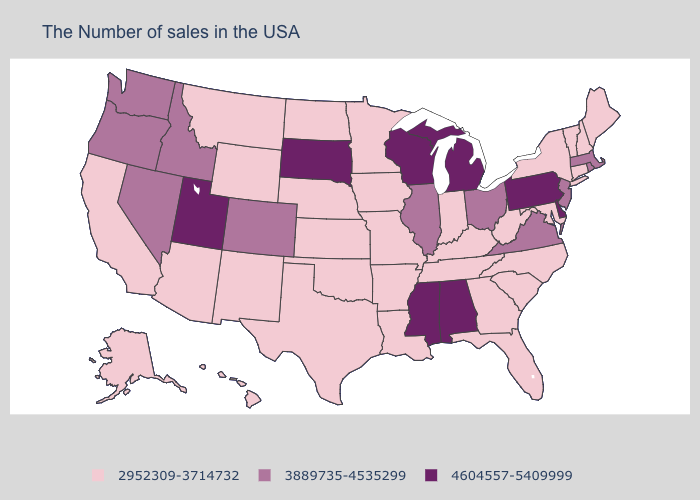Does the map have missing data?
Give a very brief answer. No. What is the highest value in states that border Kentucky?
Write a very short answer. 3889735-4535299. Is the legend a continuous bar?
Short answer required. No. Name the states that have a value in the range 4604557-5409999?
Short answer required. Delaware, Pennsylvania, Michigan, Alabama, Wisconsin, Mississippi, South Dakota, Utah. Name the states that have a value in the range 3889735-4535299?
Be succinct. Massachusetts, Rhode Island, New Jersey, Virginia, Ohio, Illinois, Colorado, Idaho, Nevada, Washington, Oregon. Name the states that have a value in the range 2952309-3714732?
Short answer required. Maine, New Hampshire, Vermont, Connecticut, New York, Maryland, North Carolina, South Carolina, West Virginia, Florida, Georgia, Kentucky, Indiana, Tennessee, Louisiana, Missouri, Arkansas, Minnesota, Iowa, Kansas, Nebraska, Oklahoma, Texas, North Dakota, Wyoming, New Mexico, Montana, Arizona, California, Alaska, Hawaii. Name the states that have a value in the range 2952309-3714732?
Concise answer only. Maine, New Hampshire, Vermont, Connecticut, New York, Maryland, North Carolina, South Carolina, West Virginia, Florida, Georgia, Kentucky, Indiana, Tennessee, Louisiana, Missouri, Arkansas, Minnesota, Iowa, Kansas, Nebraska, Oklahoma, Texas, North Dakota, Wyoming, New Mexico, Montana, Arizona, California, Alaska, Hawaii. Does Montana have the lowest value in the USA?
Concise answer only. Yes. Which states have the lowest value in the Northeast?
Give a very brief answer. Maine, New Hampshire, Vermont, Connecticut, New York. Which states have the highest value in the USA?
Be succinct. Delaware, Pennsylvania, Michigan, Alabama, Wisconsin, Mississippi, South Dakota, Utah. What is the value of Mississippi?
Be succinct. 4604557-5409999. What is the value of West Virginia?
Keep it brief. 2952309-3714732. Does South Carolina have the lowest value in the South?
Write a very short answer. Yes. Among the states that border New York , which have the highest value?
Answer briefly. Pennsylvania. 